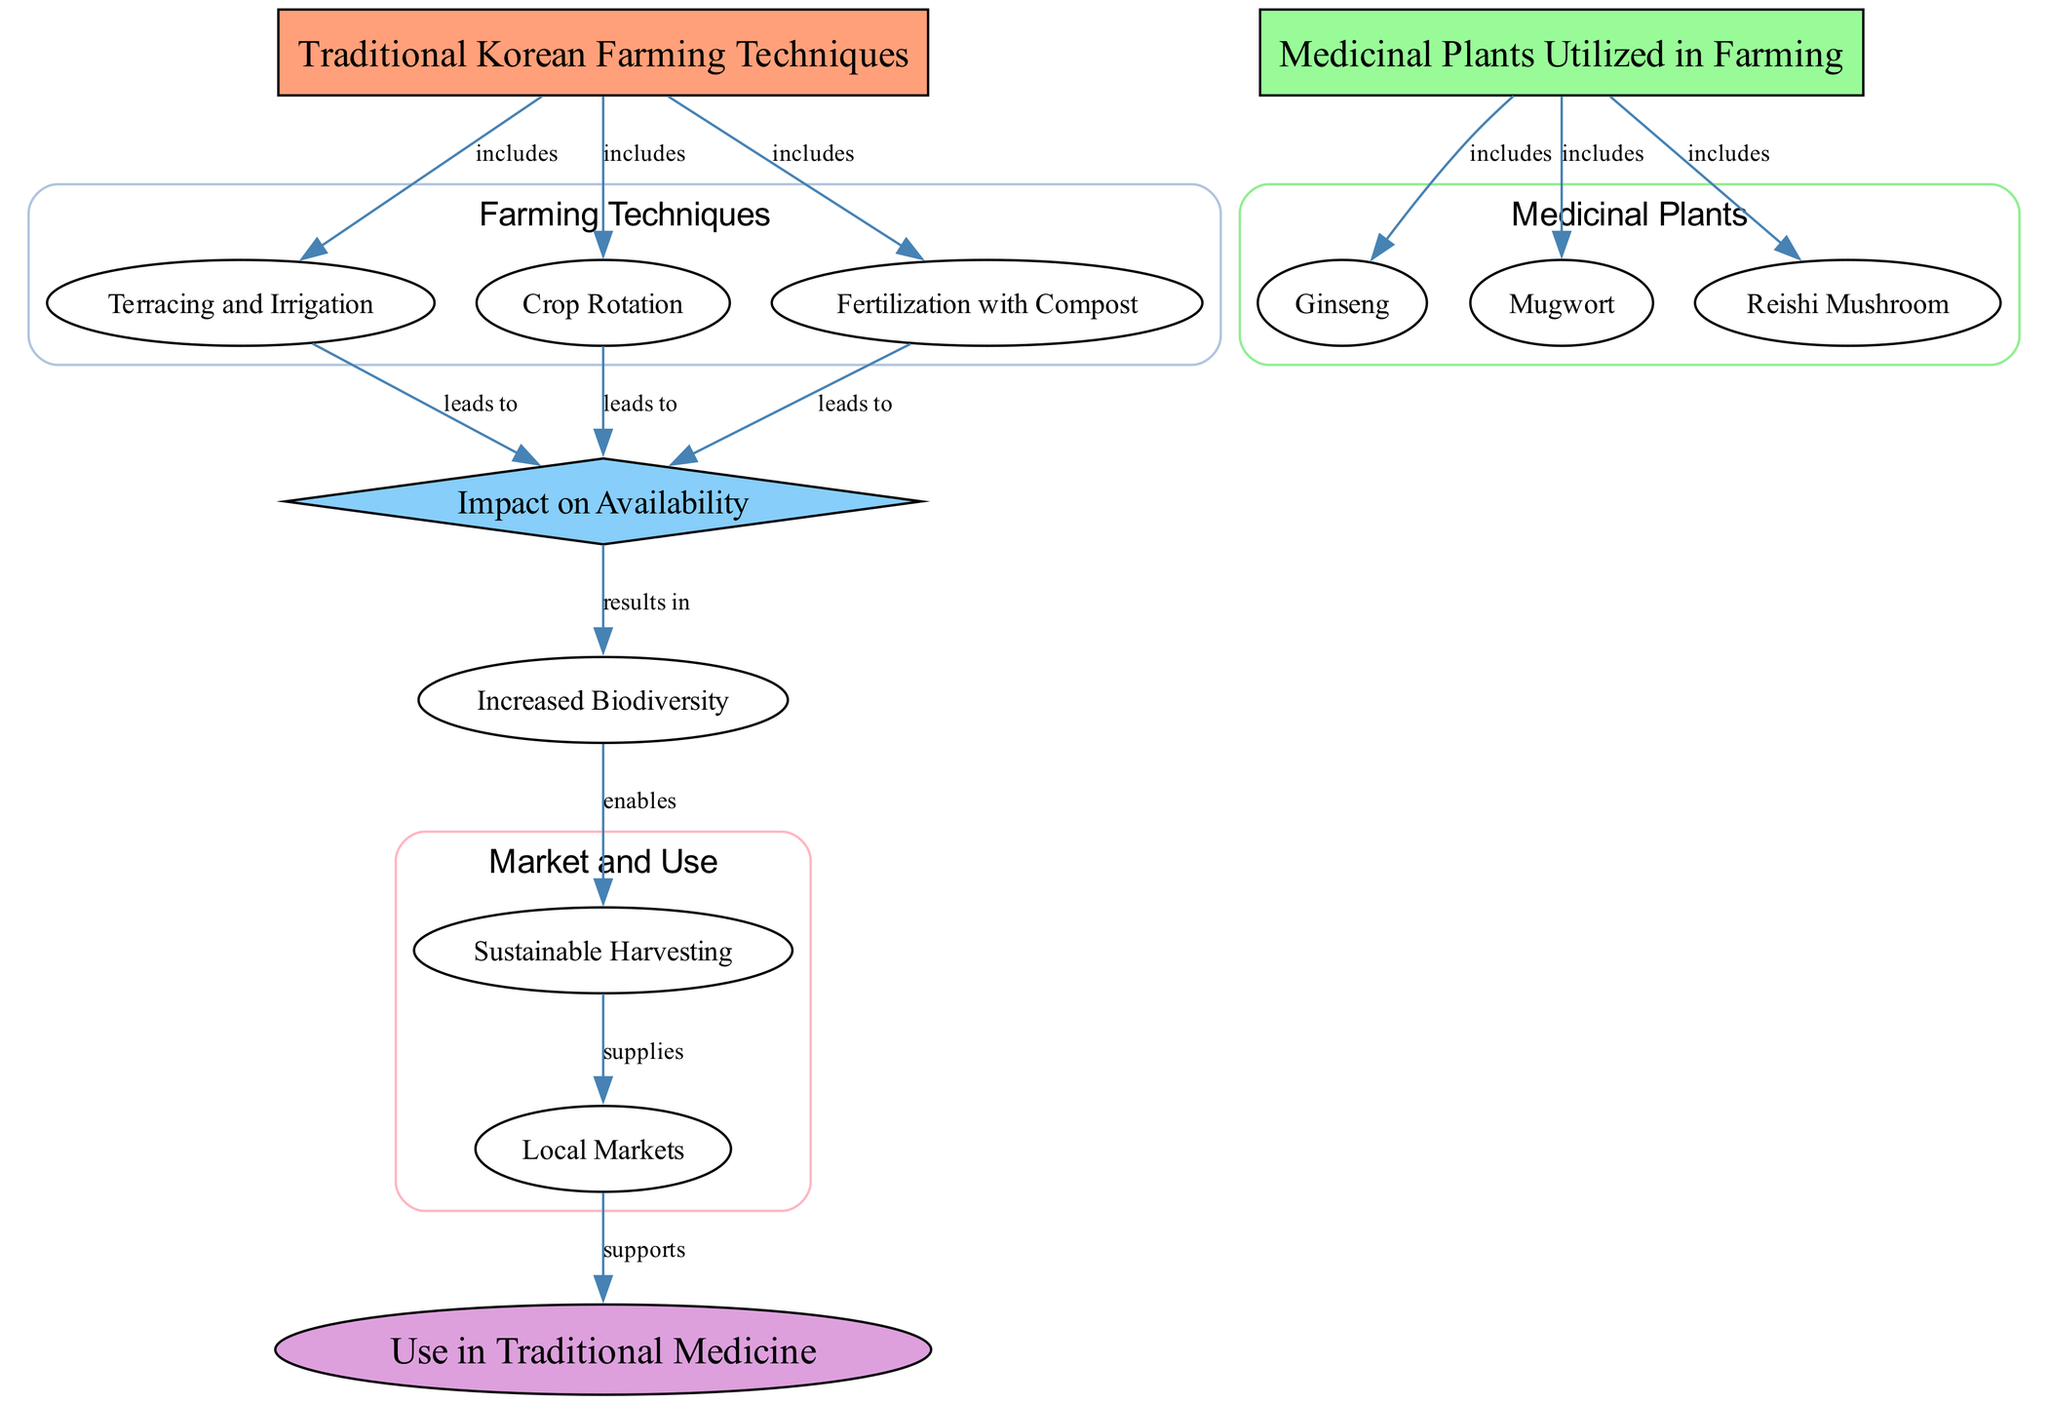What are the three farming techniques included in traditional Korean agriculture? The diagram lists three farming techniques specifically labeled under "Traditional Korean Farming Techniques": "Terracing and Irrigation," "Crop Rotation," and "Fertilization with Compost."
Answer: Terracing and Irrigation, Crop Rotation, Fertilization with Compost Which medicinal plants are included in farming according to the diagram? The diagram indicates that "Ginseng," "Mugwort," and "Reishi Mushroom" are the medicinal plants included in farming, as shown in the section about "Medicinal Plants Utilized in Farming."
Answer: Ginseng, Mugwort, Reishi Mushroom How many nodes are related to the impact on the availability of medicinal plants? The diagram visually represents three nodes leading to "Impact on Availability": "Terracing and Irrigation," "Crop Rotation," and "Fertilization with Compost," all of which directly lead to this impact.
Answer: 3 What does increased biodiversity enable according to the flow of the diagram? The diagram shows that "Increased Biodiversity" enables "Sustainable Harvesting." This relationship is indicated by the flow from the node labeled "Increased Biodiversity" to "Sustainable Harvesting."
Answer: Sustainable Harvesting What supports the use of medicinal plants in traditional medicine? The diagram illustrates that "Local Markets" supplies the use of medicinal plants, which then supports the "Use in Traditional Medicine."
Answer: Local Markets How do traditional farming techniques lead to the impact on availability? The diagram shows that all three traditional farming techniques—Terracing and Irrigation, Crop Rotation, and Fertilization with Compost—lead to "Impact on Availability," indicating that they collectively contribute to enhancing the availability of medicinal plants in farming.
Answer: All farming techniques What is the relationship between 'Fertilization with Compost' and 'Medicinal Plants Utilized in Farming'? The diagram indicates a direct relationship where "Fertilization with Compost" is included in the processes that also include the use of medicinal plants in farming, suggesting it plays a role in enhancing their growth.
Answer: Included in farming practices What is the final outcome supported by local markets? According to the flow of the diagram, the final outcome supported by local markets is "Use in Traditional Medicine," indicating a direct connection from market availability to medicinal plant applications.
Answer: Use in Traditional Medicine 